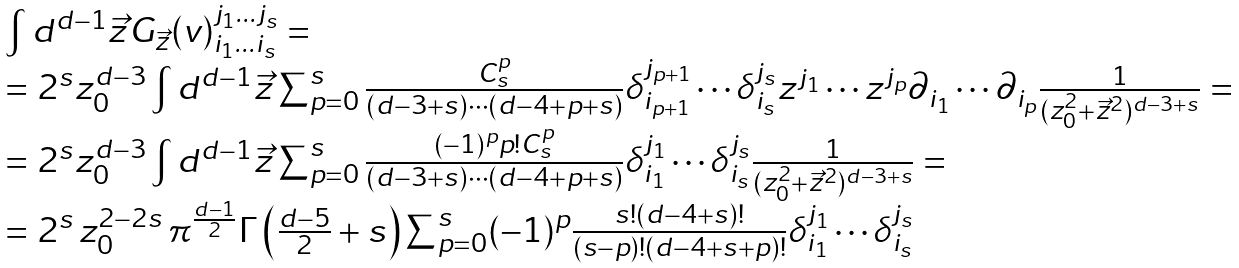<formula> <loc_0><loc_0><loc_500><loc_500>\begin{array} { l } { { \int d ^ { d - 1 } \vec { z } G _ { \vec { z } } ( v ) _ { i _ { 1 } \dots i _ { s } } ^ { j _ { 1 } \dots j _ { s } } = } } \\ { { = 2 ^ { s } z _ { 0 } ^ { d - 3 } \int d ^ { d - 1 } \vec { z } \sum _ { p = 0 } ^ { s } { \frac { C _ { s } ^ { p } } { ( d - 3 + s ) \cdots ( d - 4 + p + s ) } } \delta _ { i _ { p + 1 } } ^ { j _ { p + 1 } } \cdots \delta _ { i _ { s } } ^ { j _ { s } } z ^ { j _ { 1 } } \cdots z ^ { j _ { p } } \partial _ { i _ { 1 } } \cdots \partial _ { i _ { p } } { \frac { 1 } { ( z _ { 0 } ^ { 2 } + \vec { z } ^ { 2 } ) ^ { d - 3 + s } } } = } } \\ { { = 2 ^ { s } z _ { 0 } ^ { d - 3 } \int d ^ { d - 1 } \vec { z } \sum _ { p = 0 } ^ { s } { \frac { ( - 1 ) ^ { p } p ! C _ { s } ^ { p } } { ( d - 3 + s ) \cdots ( d - 4 + p + s ) } } \delta _ { i _ { 1 } } ^ { j _ { 1 } } \cdots \delta _ { i _ { s } } ^ { j _ { s } } { \frac { 1 } { ( z _ { 0 } ^ { 2 } + \vec { z } ^ { 2 } ) ^ { d - 3 + s } } } = } } \\ { { = 2 ^ { s } \, z _ { 0 } ^ { 2 - 2 s } \, \pi ^ { \frac { d - 1 } { 2 } } \Gamma \left ( { \frac { d - 5 } { 2 } } + s \right ) \sum _ { p = 0 } ^ { s } ( - 1 ) ^ { p } { \frac { s ! ( d - 4 + s ) ! } { ( s - p ) ! ( d - 4 + s + p ) ! } } \delta _ { i _ { 1 } } ^ { j _ { 1 } } \cdots \delta _ { i _ { s } } ^ { j _ { s } } } } \end{array}</formula> 